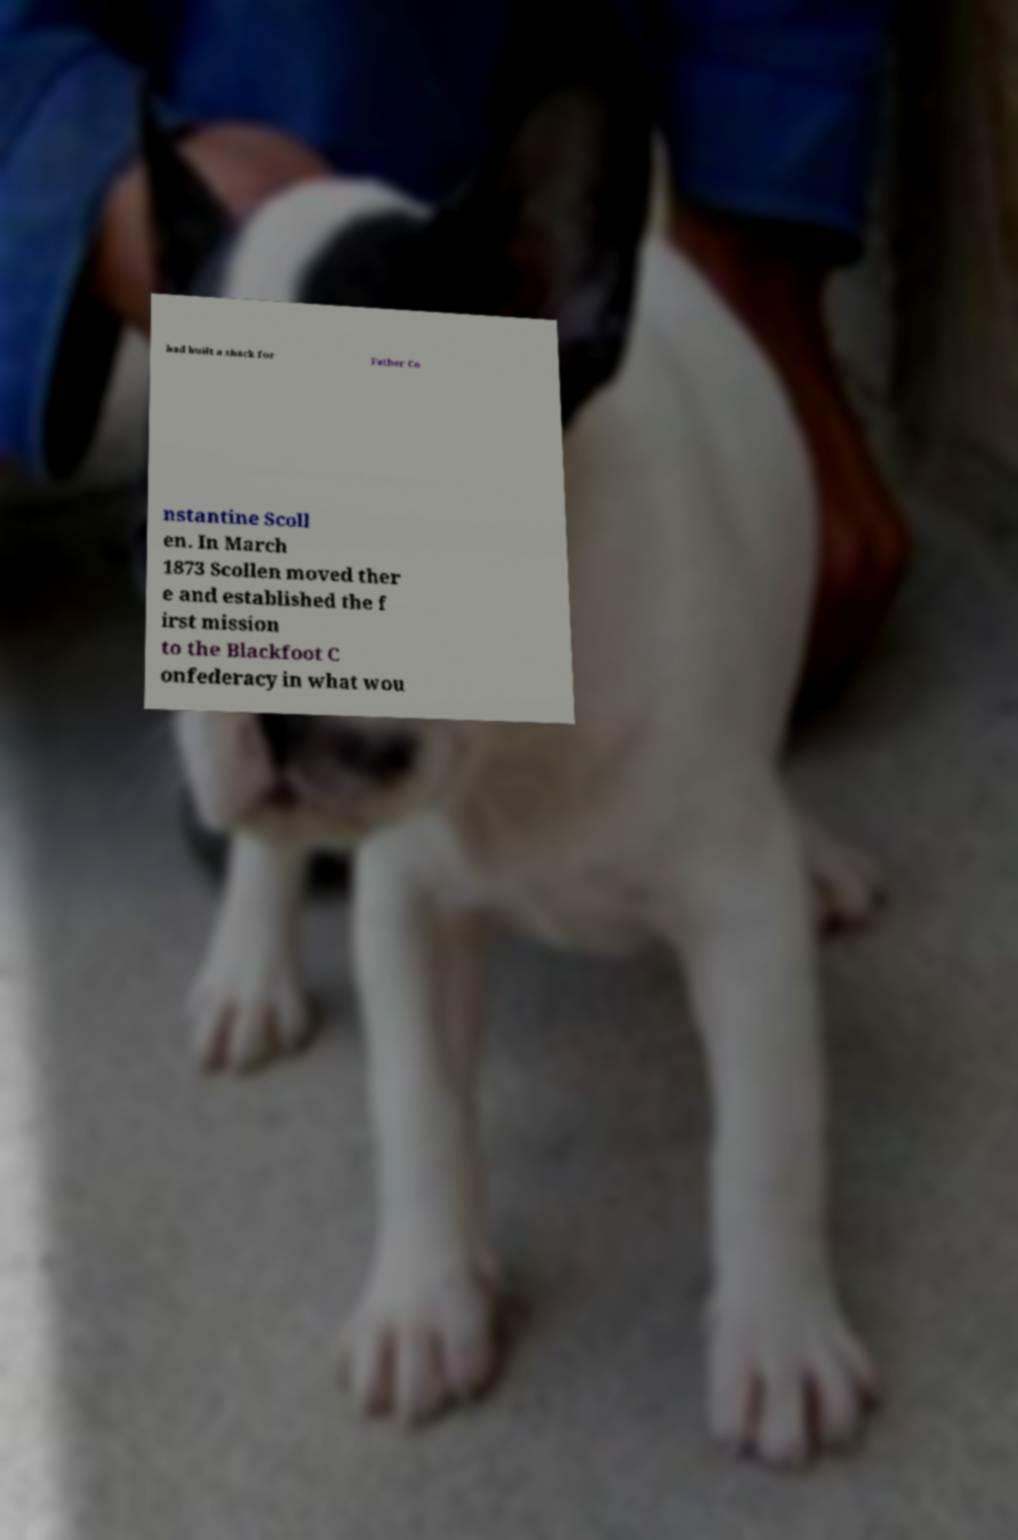I need the written content from this picture converted into text. Can you do that? had built a shack for Father Co nstantine Scoll en. In March 1873 Scollen moved ther e and established the f irst mission to the Blackfoot C onfederacy in what wou 